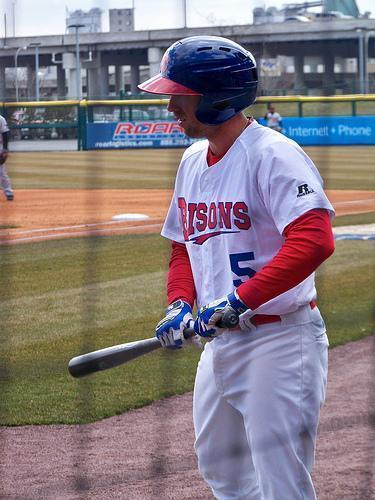How many people on the field?
Give a very brief answer. 3. 